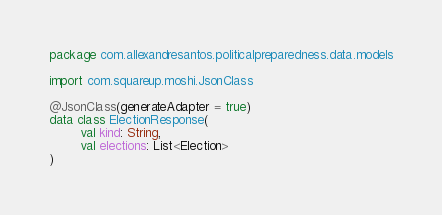Convert code to text. <code><loc_0><loc_0><loc_500><loc_500><_Kotlin_>package com.allexandresantos.politicalpreparedness.data.models

import com.squareup.moshi.JsonClass

@JsonClass(generateAdapter = true)
data class ElectionResponse(
        val kind: String,
        val elections: List<Election>
)</code> 